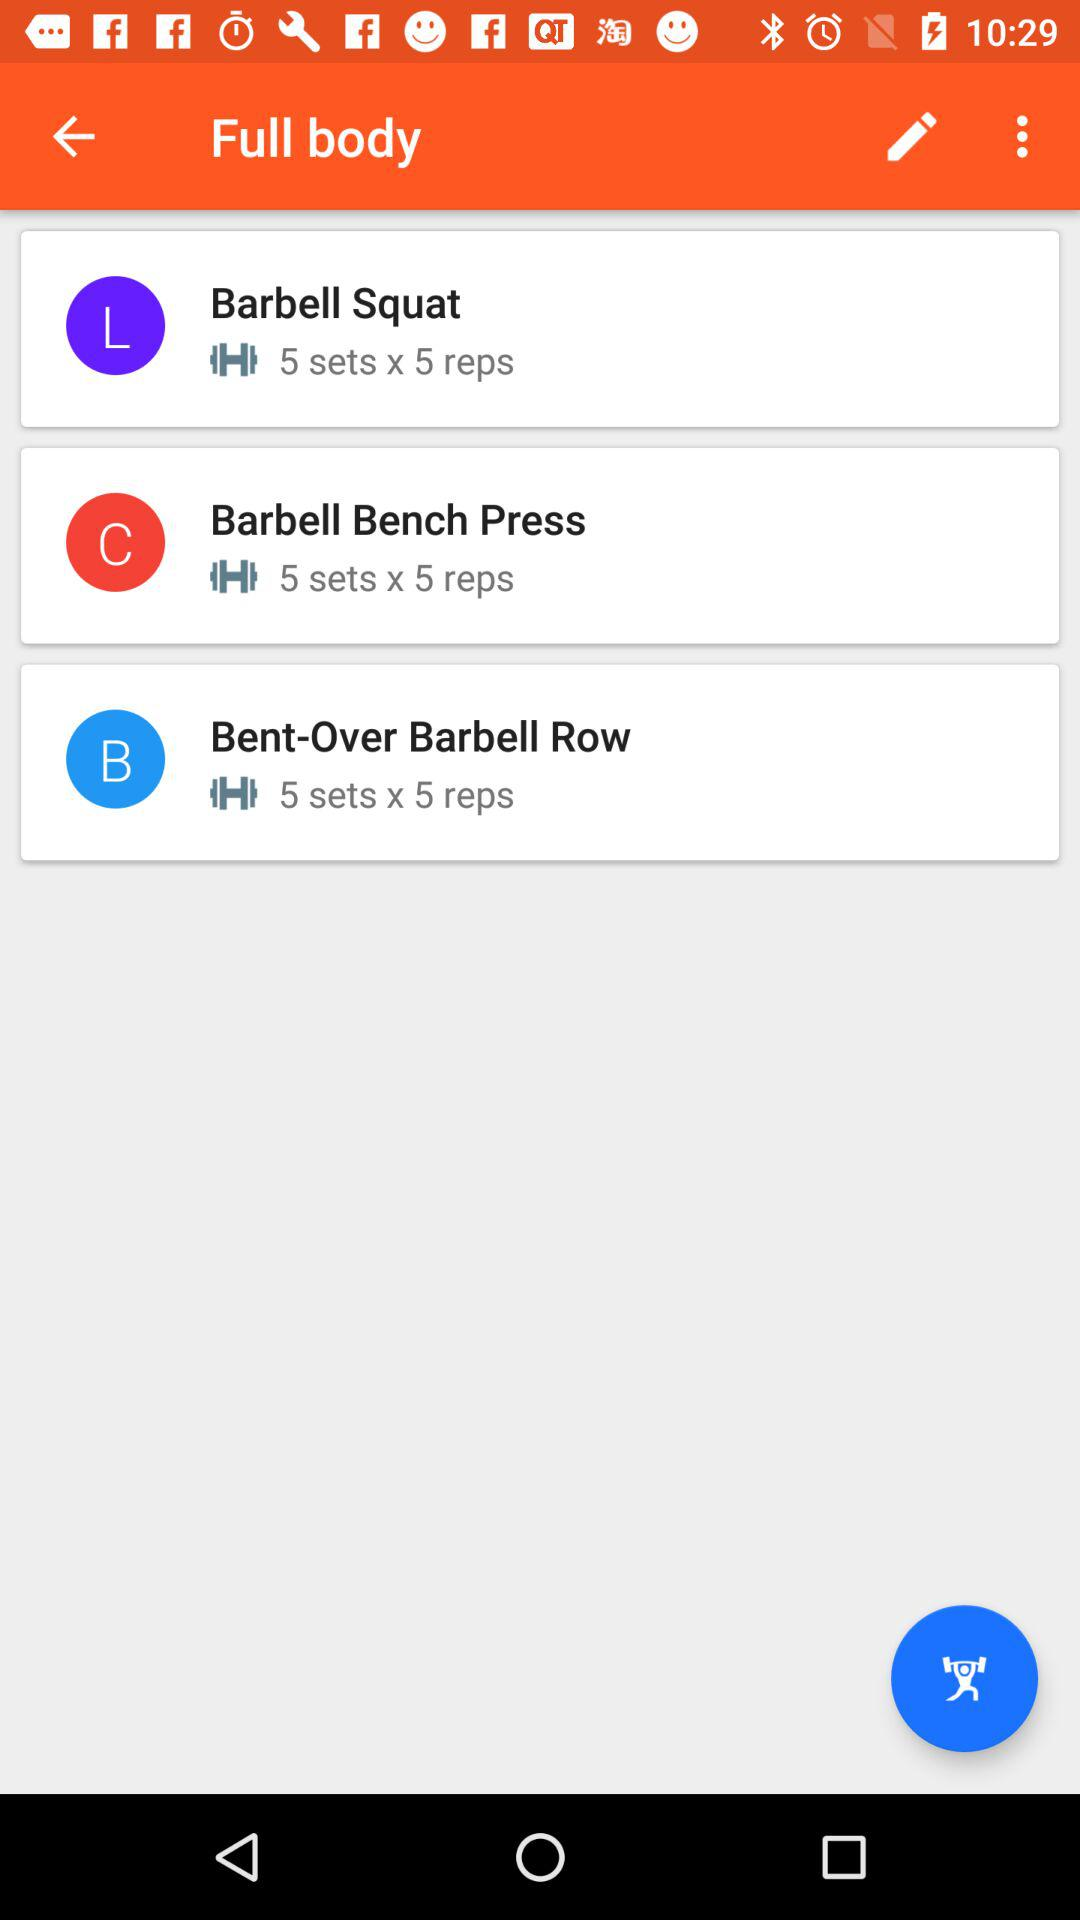What is the set count of the "Barbell Bench Press"? The count is "5 sets x 5 reps". 